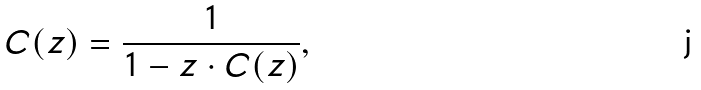Convert formula to latex. <formula><loc_0><loc_0><loc_500><loc_500>C ( z ) = { \frac { 1 } { 1 - z \cdot C ( z ) } } ,</formula> 